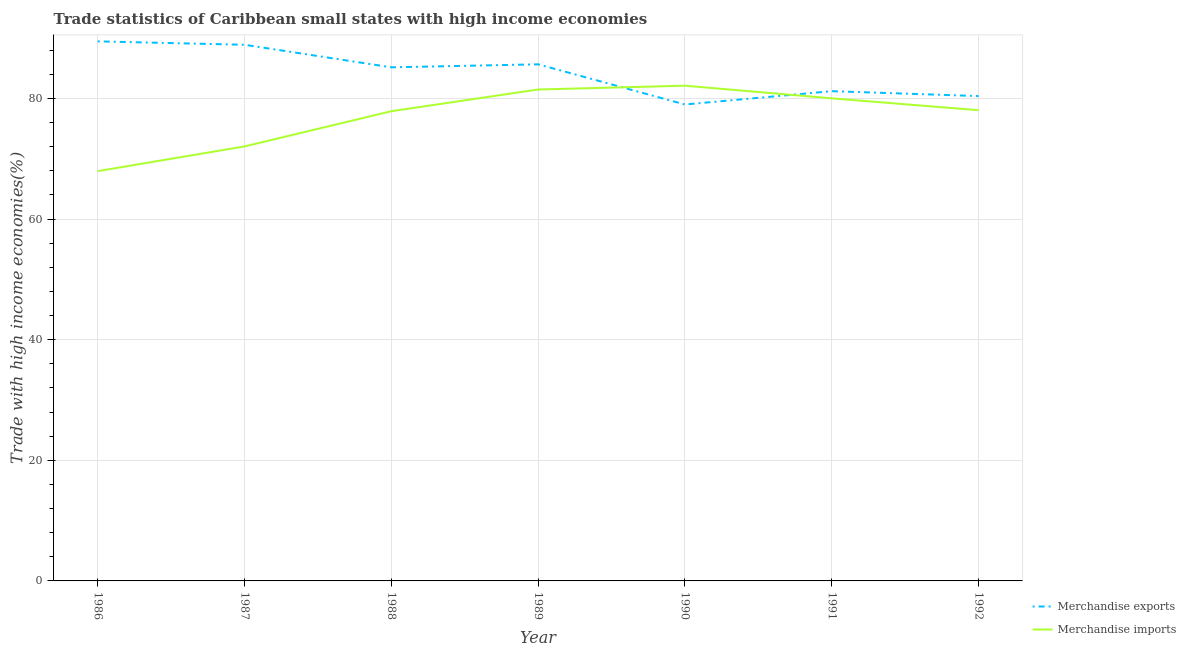Is the number of lines equal to the number of legend labels?
Keep it short and to the point. Yes. What is the merchandise imports in 1992?
Your answer should be compact. 78.06. Across all years, what is the maximum merchandise exports?
Your answer should be very brief. 89.48. Across all years, what is the minimum merchandise imports?
Your answer should be compact. 67.96. In which year was the merchandise exports maximum?
Your answer should be compact. 1986. In which year was the merchandise exports minimum?
Ensure brevity in your answer.  1990. What is the total merchandise imports in the graph?
Your answer should be very brief. 539.62. What is the difference between the merchandise exports in 1988 and that in 1991?
Provide a short and direct response. 3.96. What is the difference between the merchandise exports in 1990 and the merchandise imports in 1987?
Ensure brevity in your answer.  6.95. What is the average merchandise imports per year?
Offer a terse response. 77.09. In the year 1991, what is the difference between the merchandise imports and merchandise exports?
Your response must be concise. -1.19. What is the ratio of the merchandise exports in 1987 to that in 1988?
Ensure brevity in your answer.  1.04. What is the difference between the highest and the second highest merchandise imports?
Give a very brief answer. 0.63. What is the difference between the highest and the lowest merchandise exports?
Ensure brevity in your answer.  10.47. Is the sum of the merchandise imports in 1987 and 1992 greater than the maximum merchandise exports across all years?
Your answer should be very brief. Yes. Does the merchandise exports monotonically increase over the years?
Keep it short and to the point. No. Is the merchandise exports strictly less than the merchandise imports over the years?
Offer a very short reply. No. How many lines are there?
Your response must be concise. 2. Where does the legend appear in the graph?
Provide a short and direct response. Bottom right. How are the legend labels stacked?
Keep it short and to the point. Vertical. What is the title of the graph?
Your answer should be compact. Trade statistics of Caribbean small states with high income economies. What is the label or title of the Y-axis?
Make the answer very short. Trade with high income economies(%). What is the Trade with high income economies(%) in Merchandise exports in 1986?
Offer a very short reply. 89.48. What is the Trade with high income economies(%) of Merchandise imports in 1986?
Your answer should be compact. 67.96. What is the Trade with high income economies(%) of Merchandise exports in 1987?
Offer a very short reply. 88.91. What is the Trade with high income economies(%) of Merchandise imports in 1987?
Provide a succinct answer. 72.06. What is the Trade with high income economies(%) in Merchandise exports in 1988?
Your response must be concise. 85.17. What is the Trade with high income economies(%) of Merchandise imports in 1988?
Give a very brief answer. 77.89. What is the Trade with high income economies(%) in Merchandise exports in 1989?
Make the answer very short. 85.67. What is the Trade with high income economies(%) of Merchandise imports in 1989?
Ensure brevity in your answer.  81.5. What is the Trade with high income economies(%) in Merchandise exports in 1990?
Offer a very short reply. 79.01. What is the Trade with high income economies(%) of Merchandise imports in 1990?
Keep it short and to the point. 82.13. What is the Trade with high income economies(%) of Merchandise exports in 1991?
Keep it short and to the point. 81.22. What is the Trade with high income economies(%) in Merchandise imports in 1991?
Keep it short and to the point. 80.03. What is the Trade with high income economies(%) in Merchandise exports in 1992?
Keep it short and to the point. 80.4. What is the Trade with high income economies(%) in Merchandise imports in 1992?
Offer a very short reply. 78.06. Across all years, what is the maximum Trade with high income economies(%) of Merchandise exports?
Offer a terse response. 89.48. Across all years, what is the maximum Trade with high income economies(%) in Merchandise imports?
Provide a succinct answer. 82.13. Across all years, what is the minimum Trade with high income economies(%) of Merchandise exports?
Provide a short and direct response. 79.01. Across all years, what is the minimum Trade with high income economies(%) in Merchandise imports?
Give a very brief answer. 67.96. What is the total Trade with high income economies(%) of Merchandise exports in the graph?
Keep it short and to the point. 589.87. What is the total Trade with high income economies(%) in Merchandise imports in the graph?
Ensure brevity in your answer.  539.62. What is the difference between the Trade with high income economies(%) in Merchandise exports in 1986 and that in 1987?
Ensure brevity in your answer.  0.57. What is the difference between the Trade with high income economies(%) of Merchandise imports in 1986 and that in 1987?
Offer a very short reply. -4.1. What is the difference between the Trade with high income economies(%) in Merchandise exports in 1986 and that in 1988?
Ensure brevity in your answer.  4.3. What is the difference between the Trade with high income economies(%) of Merchandise imports in 1986 and that in 1988?
Your answer should be compact. -9.94. What is the difference between the Trade with high income economies(%) in Merchandise exports in 1986 and that in 1989?
Provide a short and direct response. 3.81. What is the difference between the Trade with high income economies(%) in Merchandise imports in 1986 and that in 1989?
Your answer should be very brief. -13.54. What is the difference between the Trade with high income economies(%) of Merchandise exports in 1986 and that in 1990?
Provide a succinct answer. 10.47. What is the difference between the Trade with high income economies(%) of Merchandise imports in 1986 and that in 1990?
Ensure brevity in your answer.  -14.17. What is the difference between the Trade with high income economies(%) of Merchandise exports in 1986 and that in 1991?
Provide a short and direct response. 8.26. What is the difference between the Trade with high income economies(%) of Merchandise imports in 1986 and that in 1991?
Provide a short and direct response. -12.08. What is the difference between the Trade with high income economies(%) of Merchandise exports in 1986 and that in 1992?
Provide a succinct answer. 9.08. What is the difference between the Trade with high income economies(%) in Merchandise imports in 1986 and that in 1992?
Keep it short and to the point. -10.1. What is the difference between the Trade with high income economies(%) in Merchandise exports in 1987 and that in 1988?
Your response must be concise. 3.74. What is the difference between the Trade with high income economies(%) of Merchandise imports in 1987 and that in 1988?
Provide a short and direct response. -5.84. What is the difference between the Trade with high income economies(%) of Merchandise exports in 1987 and that in 1989?
Keep it short and to the point. 3.24. What is the difference between the Trade with high income economies(%) in Merchandise imports in 1987 and that in 1989?
Keep it short and to the point. -9.44. What is the difference between the Trade with high income economies(%) in Merchandise exports in 1987 and that in 1990?
Ensure brevity in your answer.  9.9. What is the difference between the Trade with high income economies(%) of Merchandise imports in 1987 and that in 1990?
Make the answer very short. -10.07. What is the difference between the Trade with high income economies(%) in Merchandise exports in 1987 and that in 1991?
Ensure brevity in your answer.  7.69. What is the difference between the Trade with high income economies(%) of Merchandise imports in 1987 and that in 1991?
Ensure brevity in your answer.  -7.97. What is the difference between the Trade with high income economies(%) of Merchandise exports in 1987 and that in 1992?
Offer a terse response. 8.51. What is the difference between the Trade with high income economies(%) of Merchandise imports in 1987 and that in 1992?
Make the answer very short. -6. What is the difference between the Trade with high income economies(%) in Merchandise exports in 1988 and that in 1989?
Ensure brevity in your answer.  -0.5. What is the difference between the Trade with high income economies(%) of Merchandise imports in 1988 and that in 1989?
Give a very brief answer. -3.6. What is the difference between the Trade with high income economies(%) of Merchandise exports in 1988 and that in 1990?
Provide a short and direct response. 6.16. What is the difference between the Trade with high income economies(%) of Merchandise imports in 1988 and that in 1990?
Provide a short and direct response. -4.23. What is the difference between the Trade with high income economies(%) of Merchandise exports in 1988 and that in 1991?
Your answer should be very brief. 3.96. What is the difference between the Trade with high income economies(%) in Merchandise imports in 1988 and that in 1991?
Provide a short and direct response. -2.14. What is the difference between the Trade with high income economies(%) in Merchandise exports in 1988 and that in 1992?
Keep it short and to the point. 4.77. What is the difference between the Trade with high income economies(%) in Merchandise imports in 1988 and that in 1992?
Provide a succinct answer. -0.16. What is the difference between the Trade with high income economies(%) of Merchandise exports in 1989 and that in 1990?
Your answer should be compact. 6.66. What is the difference between the Trade with high income economies(%) in Merchandise imports in 1989 and that in 1990?
Your answer should be compact. -0.63. What is the difference between the Trade with high income economies(%) of Merchandise exports in 1989 and that in 1991?
Your answer should be compact. 4.45. What is the difference between the Trade with high income economies(%) in Merchandise imports in 1989 and that in 1991?
Provide a short and direct response. 1.46. What is the difference between the Trade with high income economies(%) of Merchandise exports in 1989 and that in 1992?
Your answer should be very brief. 5.27. What is the difference between the Trade with high income economies(%) in Merchandise imports in 1989 and that in 1992?
Offer a terse response. 3.44. What is the difference between the Trade with high income economies(%) of Merchandise exports in 1990 and that in 1991?
Your answer should be very brief. -2.21. What is the difference between the Trade with high income economies(%) in Merchandise imports in 1990 and that in 1991?
Offer a very short reply. 2.1. What is the difference between the Trade with high income economies(%) in Merchandise exports in 1990 and that in 1992?
Ensure brevity in your answer.  -1.39. What is the difference between the Trade with high income economies(%) of Merchandise imports in 1990 and that in 1992?
Provide a short and direct response. 4.07. What is the difference between the Trade with high income economies(%) of Merchandise exports in 1991 and that in 1992?
Provide a succinct answer. 0.82. What is the difference between the Trade with high income economies(%) of Merchandise imports in 1991 and that in 1992?
Provide a succinct answer. 1.97. What is the difference between the Trade with high income economies(%) of Merchandise exports in 1986 and the Trade with high income economies(%) of Merchandise imports in 1987?
Your answer should be very brief. 17.42. What is the difference between the Trade with high income economies(%) in Merchandise exports in 1986 and the Trade with high income economies(%) in Merchandise imports in 1988?
Your response must be concise. 11.58. What is the difference between the Trade with high income economies(%) of Merchandise exports in 1986 and the Trade with high income economies(%) of Merchandise imports in 1989?
Keep it short and to the point. 7.98. What is the difference between the Trade with high income economies(%) in Merchandise exports in 1986 and the Trade with high income economies(%) in Merchandise imports in 1990?
Keep it short and to the point. 7.35. What is the difference between the Trade with high income economies(%) of Merchandise exports in 1986 and the Trade with high income economies(%) of Merchandise imports in 1991?
Offer a terse response. 9.45. What is the difference between the Trade with high income economies(%) in Merchandise exports in 1986 and the Trade with high income economies(%) in Merchandise imports in 1992?
Offer a very short reply. 11.42. What is the difference between the Trade with high income economies(%) in Merchandise exports in 1987 and the Trade with high income economies(%) in Merchandise imports in 1988?
Make the answer very short. 11.02. What is the difference between the Trade with high income economies(%) in Merchandise exports in 1987 and the Trade with high income economies(%) in Merchandise imports in 1989?
Keep it short and to the point. 7.42. What is the difference between the Trade with high income economies(%) in Merchandise exports in 1987 and the Trade with high income economies(%) in Merchandise imports in 1990?
Keep it short and to the point. 6.79. What is the difference between the Trade with high income economies(%) in Merchandise exports in 1987 and the Trade with high income economies(%) in Merchandise imports in 1991?
Provide a short and direct response. 8.88. What is the difference between the Trade with high income economies(%) of Merchandise exports in 1987 and the Trade with high income economies(%) of Merchandise imports in 1992?
Your answer should be very brief. 10.85. What is the difference between the Trade with high income economies(%) of Merchandise exports in 1988 and the Trade with high income economies(%) of Merchandise imports in 1989?
Offer a very short reply. 3.68. What is the difference between the Trade with high income economies(%) in Merchandise exports in 1988 and the Trade with high income economies(%) in Merchandise imports in 1990?
Keep it short and to the point. 3.05. What is the difference between the Trade with high income economies(%) in Merchandise exports in 1988 and the Trade with high income economies(%) in Merchandise imports in 1991?
Provide a short and direct response. 5.14. What is the difference between the Trade with high income economies(%) in Merchandise exports in 1988 and the Trade with high income economies(%) in Merchandise imports in 1992?
Ensure brevity in your answer.  7.11. What is the difference between the Trade with high income economies(%) in Merchandise exports in 1989 and the Trade with high income economies(%) in Merchandise imports in 1990?
Keep it short and to the point. 3.54. What is the difference between the Trade with high income economies(%) in Merchandise exports in 1989 and the Trade with high income economies(%) in Merchandise imports in 1991?
Your response must be concise. 5.64. What is the difference between the Trade with high income economies(%) in Merchandise exports in 1989 and the Trade with high income economies(%) in Merchandise imports in 1992?
Your answer should be compact. 7.61. What is the difference between the Trade with high income economies(%) of Merchandise exports in 1990 and the Trade with high income economies(%) of Merchandise imports in 1991?
Your answer should be compact. -1.02. What is the difference between the Trade with high income economies(%) in Merchandise exports in 1990 and the Trade with high income economies(%) in Merchandise imports in 1992?
Your response must be concise. 0.95. What is the difference between the Trade with high income economies(%) of Merchandise exports in 1991 and the Trade with high income economies(%) of Merchandise imports in 1992?
Offer a very short reply. 3.16. What is the average Trade with high income economies(%) of Merchandise exports per year?
Your answer should be compact. 84.27. What is the average Trade with high income economies(%) in Merchandise imports per year?
Ensure brevity in your answer.  77.09. In the year 1986, what is the difference between the Trade with high income economies(%) in Merchandise exports and Trade with high income economies(%) in Merchandise imports?
Give a very brief answer. 21.52. In the year 1987, what is the difference between the Trade with high income economies(%) in Merchandise exports and Trade with high income economies(%) in Merchandise imports?
Provide a succinct answer. 16.85. In the year 1988, what is the difference between the Trade with high income economies(%) in Merchandise exports and Trade with high income economies(%) in Merchandise imports?
Your answer should be compact. 7.28. In the year 1989, what is the difference between the Trade with high income economies(%) in Merchandise exports and Trade with high income economies(%) in Merchandise imports?
Your answer should be very brief. 4.18. In the year 1990, what is the difference between the Trade with high income economies(%) in Merchandise exports and Trade with high income economies(%) in Merchandise imports?
Keep it short and to the point. -3.12. In the year 1991, what is the difference between the Trade with high income economies(%) of Merchandise exports and Trade with high income economies(%) of Merchandise imports?
Give a very brief answer. 1.19. In the year 1992, what is the difference between the Trade with high income economies(%) of Merchandise exports and Trade with high income economies(%) of Merchandise imports?
Give a very brief answer. 2.34. What is the ratio of the Trade with high income economies(%) of Merchandise exports in 1986 to that in 1987?
Your response must be concise. 1.01. What is the ratio of the Trade with high income economies(%) of Merchandise imports in 1986 to that in 1987?
Your answer should be compact. 0.94. What is the ratio of the Trade with high income economies(%) in Merchandise exports in 1986 to that in 1988?
Provide a succinct answer. 1.05. What is the ratio of the Trade with high income economies(%) of Merchandise imports in 1986 to that in 1988?
Your answer should be very brief. 0.87. What is the ratio of the Trade with high income economies(%) of Merchandise exports in 1986 to that in 1989?
Offer a very short reply. 1.04. What is the ratio of the Trade with high income economies(%) of Merchandise imports in 1986 to that in 1989?
Offer a terse response. 0.83. What is the ratio of the Trade with high income economies(%) of Merchandise exports in 1986 to that in 1990?
Offer a terse response. 1.13. What is the ratio of the Trade with high income economies(%) in Merchandise imports in 1986 to that in 1990?
Your answer should be very brief. 0.83. What is the ratio of the Trade with high income economies(%) in Merchandise exports in 1986 to that in 1991?
Keep it short and to the point. 1.1. What is the ratio of the Trade with high income economies(%) in Merchandise imports in 1986 to that in 1991?
Provide a succinct answer. 0.85. What is the ratio of the Trade with high income economies(%) of Merchandise exports in 1986 to that in 1992?
Your answer should be compact. 1.11. What is the ratio of the Trade with high income economies(%) in Merchandise imports in 1986 to that in 1992?
Offer a very short reply. 0.87. What is the ratio of the Trade with high income economies(%) of Merchandise exports in 1987 to that in 1988?
Keep it short and to the point. 1.04. What is the ratio of the Trade with high income economies(%) of Merchandise imports in 1987 to that in 1988?
Ensure brevity in your answer.  0.93. What is the ratio of the Trade with high income economies(%) in Merchandise exports in 1987 to that in 1989?
Provide a short and direct response. 1.04. What is the ratio of the Trade with high income economies(%) in Merchandise imports in 1987 to that in 1989?
Provide a succinct answer. 0.88. What is the ratio of the Trade with high income economies(%) of Merchandise exports in 1987 to that in 1990?
Provide a succinct answer. 1.13. What is the ratio of the Trade with high income economies(%) in Merchandise imports in 1987 to that in 1990?
Your answer should be compact. 0.88. What is the ratio of the Trade with high income economies(%) in Merchandise exports in 1987 to that in 1991?
Ensure brevity in your answer.  1.09. What is the ratio of the Trade with high income economies(%) of Merchandise imports in 1987 to that in 1991?
Provide a short and direct response. 0.9. What is the ratio of the Trade with high income economies(%) in Merchandise exports in 1987 to that in 1992?
Give a very brief answer. 1.11. What is the ratio of the Trade with high income economies(%) in Merchandise imports in 1987 to that in 1992?
Your answer should be very brief. 0.92. What is the ratio of the Trade with high income economies(%) in Merchandise exports in 1988 to that in 1989?
Make the answer very short. 0.99. What is the ratio of the Trade with high income economies(%) in Merchandise imports in 1988 to that in 1989?
Provide a short and direct response. 0.96. What is the ratio of the Trade with high income economies(%) in Merchandise exports in 1988 to that in 1990?
Your answer should be compact. 1.08. What is the ratio of the Trade with high income economies(%) in Merchandise imports in 1988 to that in 1990?
Provide a short and direct response. 0.95. What is the ratio of the Trade with high income economies(%) of Merchandise exports in 1988 to that in 1991?
Offer a very short reply. 1.05. What is the ratio of the Trade with high income economies(%) in Merchandise imports in 1988 to that in 1991?
Provide a short and direct response. 0.97. What is the ratio of the Trade with high income economies(%) in Merchandise exports in 1988 to that in 1992?
Keep it short and to the point. 1.06. What is the ratio of the Trade with high income economies(%) of Merchandise imports in 1988 to that in 1992?
Make the answer very short. 1. What is the ratio of the Trade with high income economies(%) in Merchandise exports in 1989 to that in 1990?
Offer a terse response. 1.08. What is the ratio of the Trade with high income economies(%) in Merchandise exports in 1989 to that in 1991?
Provide a short and direct response. 1.05. What is the ratio of the Trade with high income economies(%) of Merchandise imports in 1989 to that in 1991?
Offer a terse response. 1.02. What is the ratio of the Trade with high income economies(%) of Merchandise exports in 1989 to that in 1992?
Ensure brevity in your answer.  1.07. What is the ratio of the Trade with high income economies(%) of Merchandise imports in 1989 to that in 1992?
Give a very brief answer. 1.04. What is the ratio of the Trade with high income economies(%) in Merchandise exports in 1990 to that in 1991?
Your answer should be compact. 0.97. What is the ratio of the Trade with high income economies(%) in Merchandise imports in 1990 to that in 1991?
Provide a short and direct response. 1.03. What is the ratio of the Trade with high income economies(%) of Merchandise exports in 1990 to that in 1992?
Your response must be concise. 0.98. What is the ratio of the Trade with high income economies(%) of Merchandise imports in 1990 to that in 1992?
Give a very brief answer. 1.05. What is the ratio of the Trade with high income economies(%) of Merchandise exports in 1991 to that in 1992?
Give a very brief answer. 1.01. What is the ratio of the Trade with high income economies(%) of Merchandise imports in 1991 to that in 1992?
Keep it short and to the point. 1.03. What is the difference between the highest and the second highest Trade with high income economies(%) of Merchandise exports?
Make the answer very short. 0.57. What is the difference between the highest and the second highest Trade with high income economies(%) of Merchandise imports?
Ensure brevity in your answer.  0.63. What is the difference between the highest and the lowest Trade with high income economies(%) in Merchandise exports?
Your response must be concise. 10.47. What is the difference between the highest and the lowest Trade with high income economies(%) of Merchandise imports?
Make the answer very short. 14.17. 